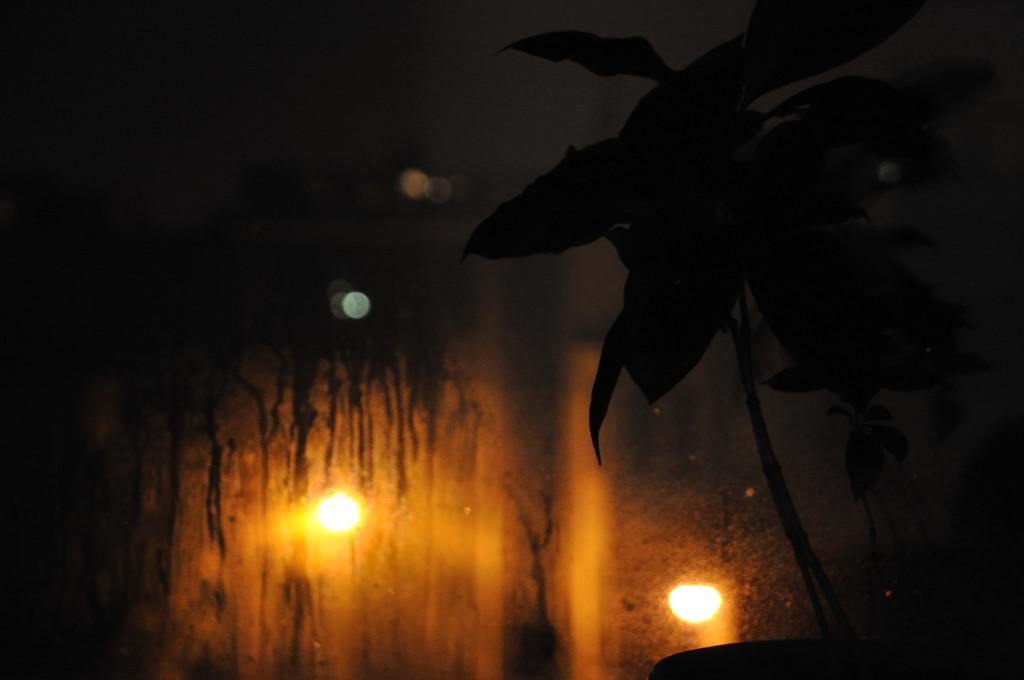How would you summarize this image in a sentence or two? In this picture I can see a plant and a glass, from the glass I can see couple of lights and a dark background. 